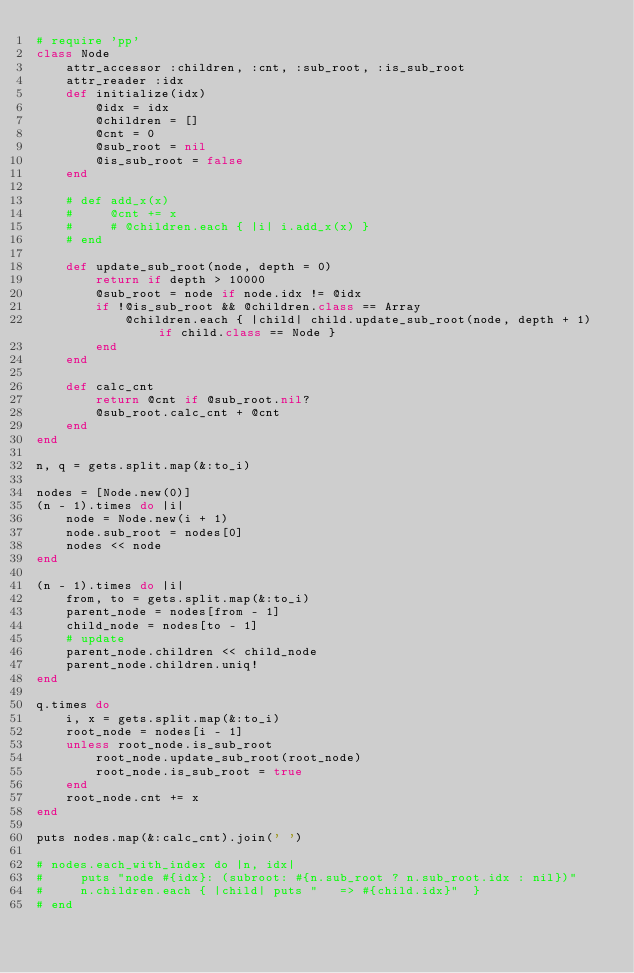<code> <loc_0><loc_0><loc_500><loc_500><_Ruby_># require 'pp'
class Node
    attr_accessor :children, :cnt, :sub_root, :is_sub_root
    attr_reader :idx
    def initialize(idx)
        @idx = idx
        @children = []
        @cnt = 0
        @sub_root = nil
        @is_sub_root = false
    end

    # def add_x(x)
    #     @cnt += x
    #     # @children.each { |i| i.add_x(x) }
    # end

    def update_sub_root(node, depth = 0)
        return if depth > 10000
        @sub_root = node if node.idx != @idx
        if !@is_sub_root && @children.class == Array
            @children.each { |child| child.update_sub_root(node, depth + 1) if child.class == Node }
        end
    end

    def calc_cnt
        return @cnt if @sub_root.nil?
        @sub_root.calc_cnt + @cnt
    end
end

n, q = gets.split.map(&:to_i)

nodes = [Node.new(0)]
(n - 1).times do |i| 
    node = Node.new(i + 1)
    node.sub_root = nodes[0]
    nodes << node
end

(n - 1).times do |i|
    from, to = gets.split.map(&:to_i)
    parent_node = nodes[from - 1]
    child_node = nodes[to - 1]
    # update
    parent_node.children << child_node
    parent_node.children.uniq!
end

q.times do
    i, x = gets.split.map(&:to_i)
    root_node = nodes[i - 1]
    unless root_node.is_sub_root
        root_node.update_sub_root(root_node)
        root_node.is_sub_root = true
    end
    root_node.cnt += x
end

puts nodes.map(&:calc_cnt).join(' ')

# nodes.each_with_index do |n, idx|
#     puts "node #{idx}: (subroot: #{n.sub_root ? n.sub_root.idx : nil})"
#     n.children.each { |child| puts "   => #{child.idx}"  }
# end

</code> 